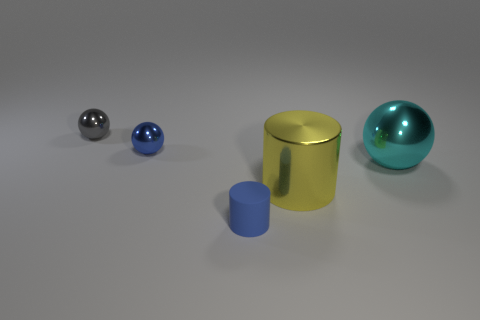What color is the large shiny sphere?
Your answer should be compact. Cyan. There is a metallic sphere that is the same size as the blue metal object; what color is it?
Provide a succinct answer. Gray. There is a tiny blue thing behind the blue cylinder; is its shape the same as the tiny matte thing?
Provide a short and direct response. No. There is a big thing on the left side of the ball that is on the right side of the large metallic object left of the large cyan shiny thing; what color is it?
Your answer should be very brief. Yellow. Are any tiny gray cylinders visible?
Your answer should be very brief. No. How many other things are the same size as the yellow metal object?
Your answer should be very brief. 1. Does the small rubber object have the same color as the tiny object left of the blue metallic thing?
Provide a short and direct response. No. What number of objects are either big purple matte blocks or tiny blue things?
Your answer should be very brief. 2. Is there any other thing that is the same color as the small matte object?
Your response must be concise. Yes. Do the large cylinder and the tiny object in front of the cyan shiny object have the same material?
Make the answer very short. No. 